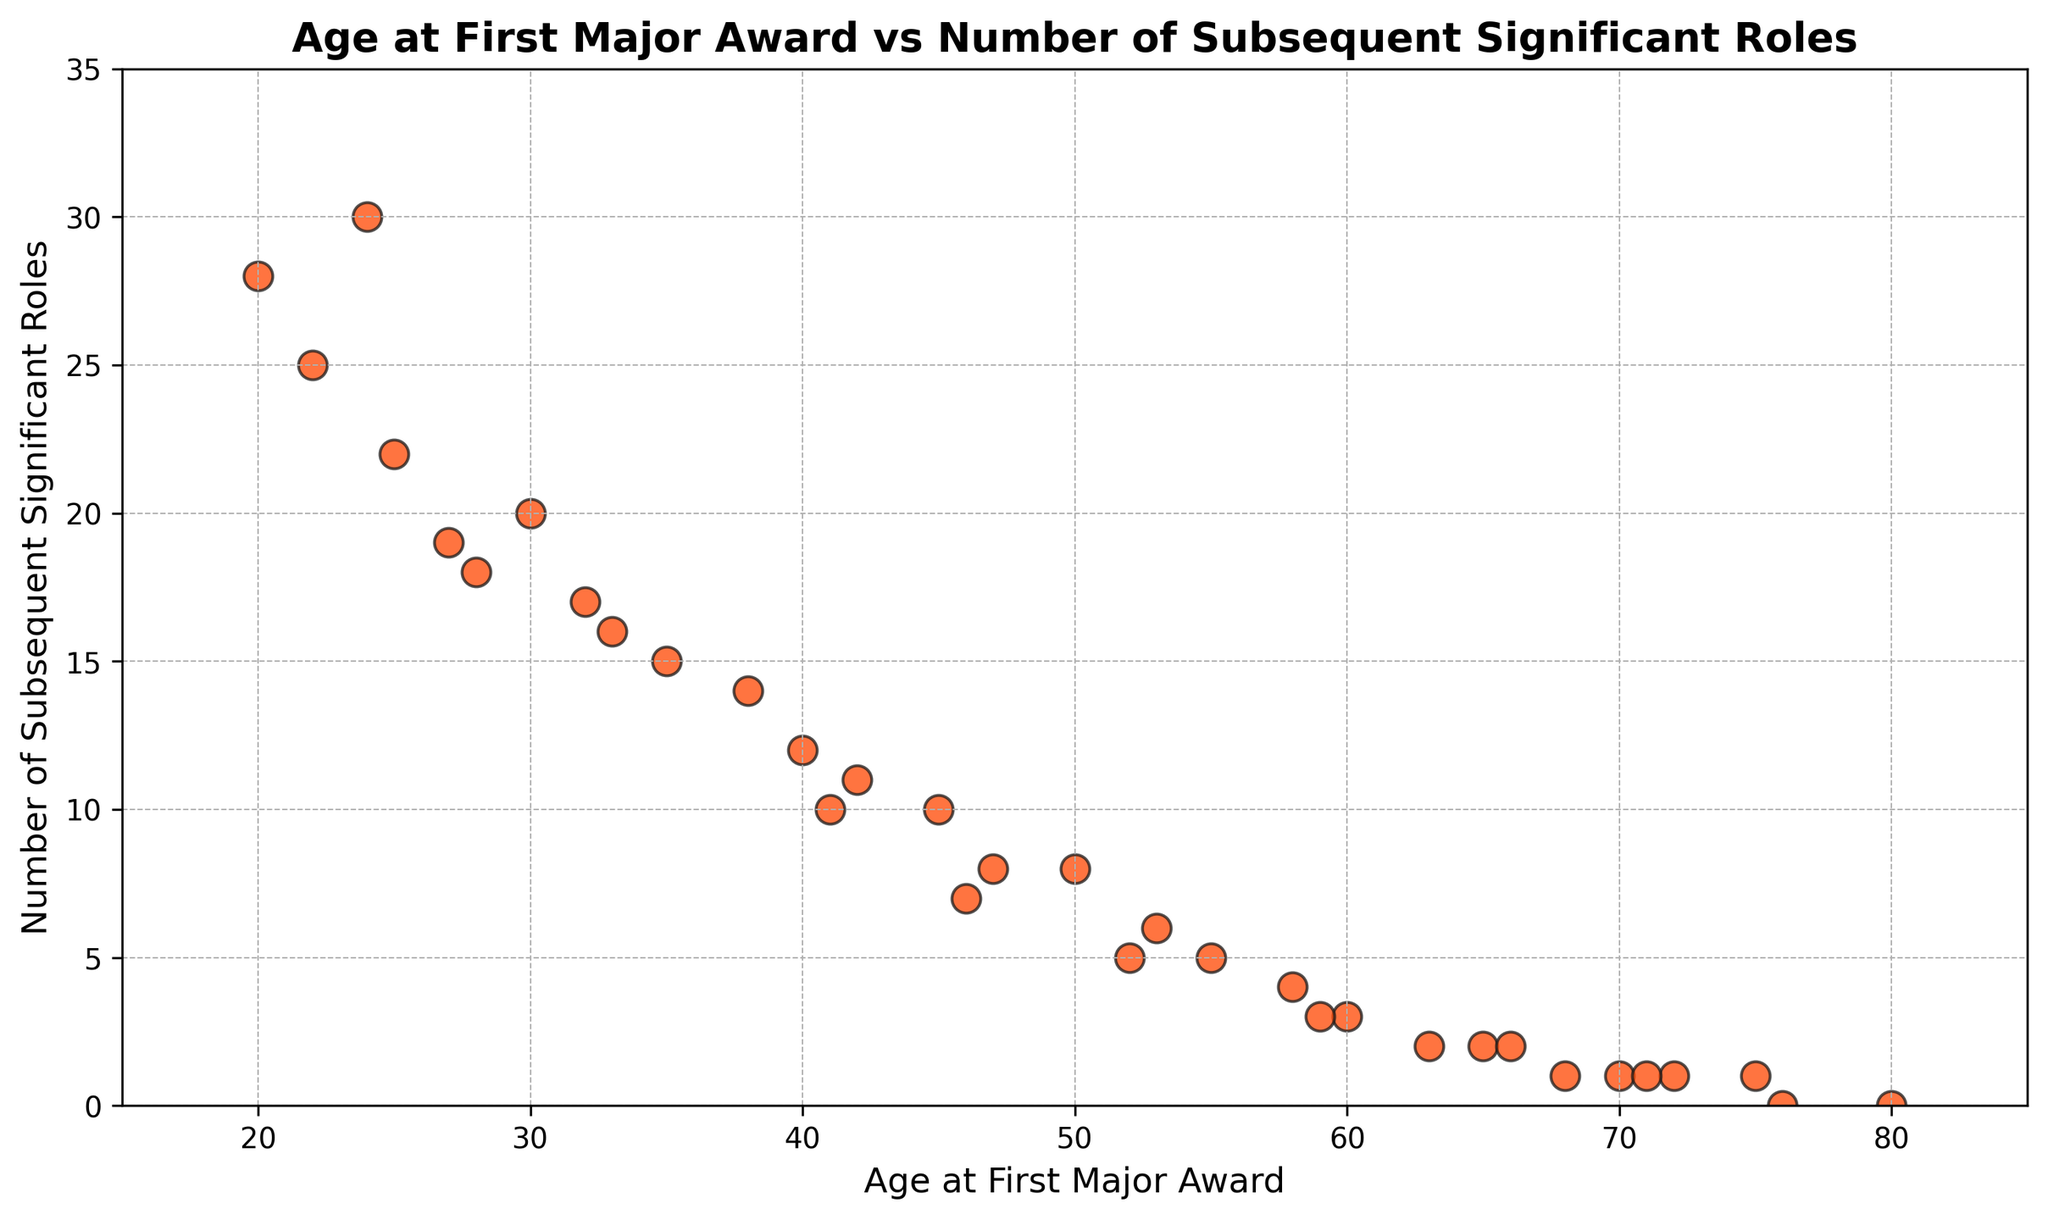What's the general trend between the age of actors at the time of their first major award and the number of their subsequent significant roles? Observing the scatter plot, we see that as the age at which actors win their first major award increases, the number of subsequent significant roles decreases. This indicates a negative correlation between these two variables.
Answer: Negative correlation Which actor age group has the highest number of subsequent significant roles? By examining the scatter plot, the group that stands out with the highest number of subsequent significant roles are those actors who received their first major award at the age of 20.
Answer: Age 20 How many subsequent significant roles do actors who win their first award at age 55 typically have? Looking at the specific data point for actors who win their first major award at age 55, we can see they typically have around 5 subsequent significant roles.
Answer: 5 Compare the number of subsequent significant roles for actors who won their first major award at age 30 with those who won at age 40. From the scatter plot, actors who won at age 30 have around 20 roles, while those who won at age 40 have around 12. Therefore, actors who won at age 30 had 8 more roles on average compared to those who won at age 40.
Answer: 8 more at age 30 What is the range of subsequent significant roles for actors who won their first major award between ages 45 and 50? By examining the ages 45 and 50 in the plot, we see they have subsequent roles ranging from 10 to 8, respectively. Thus, the range is from 8 to 10 roles.
Answer: 8 to 10 Does any age group have exactly 0 subsequent significant roles? Observing all data points, we see that actors who received their first major award at the ages of 80 and 76 have 0 subsequent significant roles.
Answer: Yes, at ages 80 and 76 What's the difference in subsequent significant roles between the youngest and the oldest actor receiving their first major award? The youngest actors in the dataset received the awards at age 20 and had 28 subsequent roles. The oldest actors received it at age 80, with 0 roles. The difference is 28 - 0 = 28 roles.
Answer: 28 roles Which age group shows the most considerable decrease in the number of subsequent roles compared to the previous age group? To find the most significant decrease, we compare nodes adjacent in age. The largest drop appears between ages 24 (30 roles) and 30 (20 roles)—a decrease of 10 roles.
Answer: Between ages 24 and 30 What can be deduced about actors who win their first major award after age 70? Observing the data points for ages above 70, those who win their first award after this age generally have 1 or no subsequent significant roles.
Answer: Few to no roles 